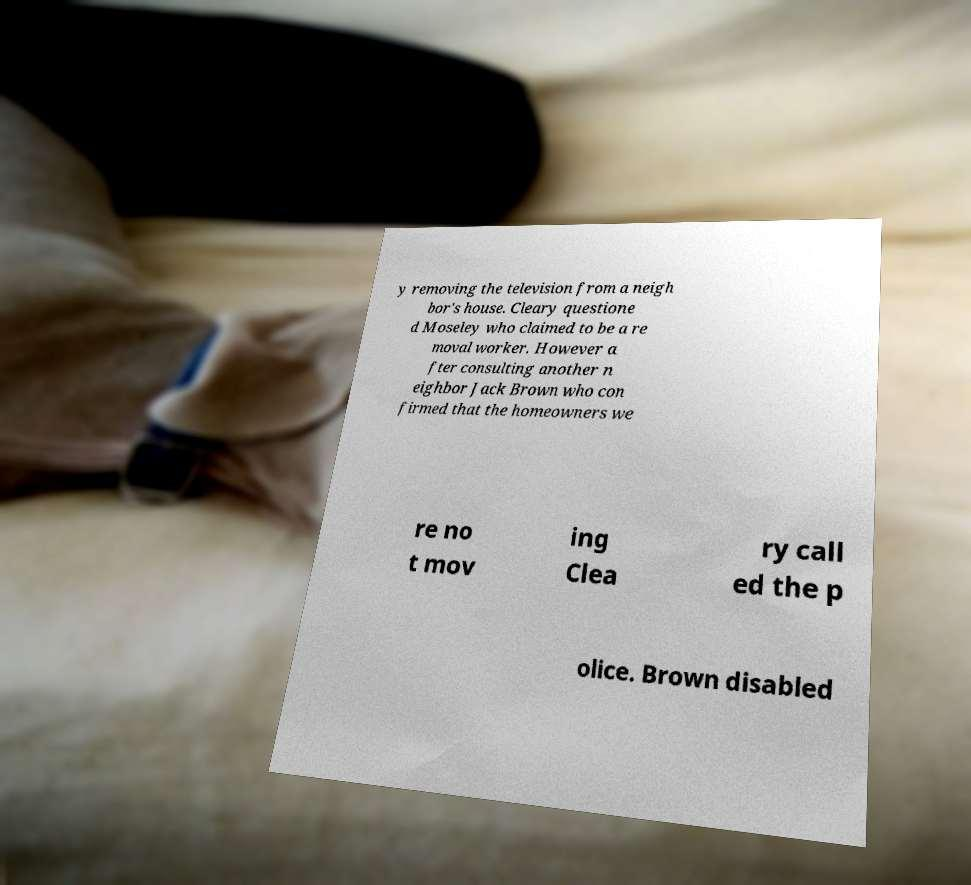Could you extract and type out the text from this image? y removing the television from a neigh bor's house. Cleary questione d Moseley who claimed to be a re moval worker. However a fter consulting another n eighbor Jack Brown who con firmed that the homeowners we re no t mov ing Clea ry call ed the p olice. Brown disabled 